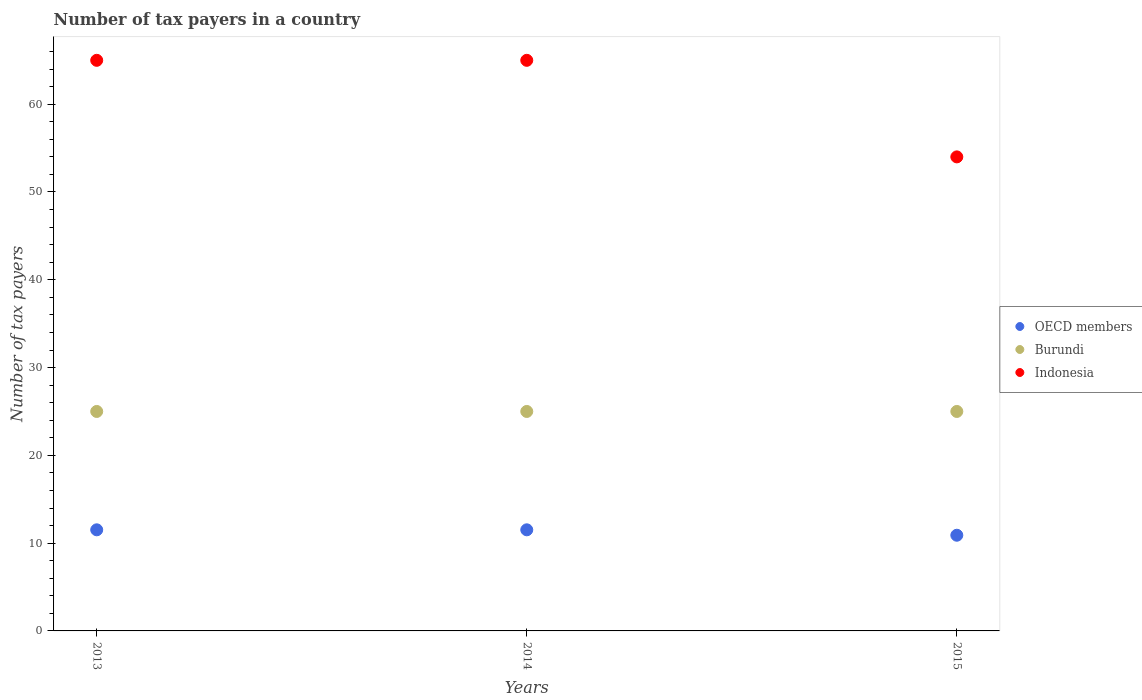What is the number of tax payers in in Indonesia in 2013?
Your response must be concise. 65. Across all years, what is the maximum number of tax payers in in Burundi?
Provide a succinct answer. 25. Across all years, what is the minimum number of tax payers in in Burundi?
Offer a very short reply. 25. In which year was the number of tax payers in in OECD members minimum?
Keep it short and to the point. 2015. What is the total number of tax payers in in Burundi in the graph?
Make the answer very short. 75. What is the difference between the number of tax payers in in OECD members in 2015 and the number of tax payers in in Burundi in 2014?
Offer a very short reply. -14.1. In the year 2013, what is the difference between the number of tax payers in in OECD members and number of tax payers in in Burundi?
Offer a terse response. -13.48. In how many years, is the number of tax payers in in OECD members greater than 16?
Keep it short and to the point. 0. What is the ratio of the number of tax payers in in OECD members in 2014 to that in 2015?
Keep it short and to the point. 1.06. Is the number of tax payers in in OECD members in 2013 less than that in 2015?
Give a very brief answer. No. What is the difference between the highest and the second highest number of tax payers in in Burundi?
Your answer should be very brief. 0. In how many years, is the number of tax payers in in Indonesia greater than the average number of tax payers in in Indonesia taken over all years?
Give a very brief answer. 2. Is the sum of the number of tax payers in in OECD members in 2013 and 2014 greater than the maximum number of tax payers in in Burundi across all years?
Your answer should be compact. No. Does the number of tax payers in in Burundi monotonically increase over the years?
Your answer should be very brief. No. Is the number of tax payers in in Burundi strictly greater than the number of tax payers in in OECD members over the years?
Offer a terse response. Yes. Is the number of tax payers in in OECD members strictly less than the number of tax payers in in Burundi over the years?
Give a very brief answer. Yes. How many dotlines are there?
Offer a terse response. 3. How many years are there in the graph?
Make the answer very short. 3. Does the graph contain any zero values?
Your answer should be compact. No. Where does the legend appear in the graph?
Your answer should be compact. Center right. How many legend labels are there?
Make the answer very short. 3. What is the title of the graph?
Ensure brevity in your answer.  Number of tax payers in a country. What is the label or title of the X-axis?
Ensure brevity in your answer.  Years. What is the label or title of the Y-axis?
Your answer should be very brief. Number of tax payers. What is the Number of tax payers in OECD members in 2013?
Provide a short and direct response. 11.52. What is the Number of tax payers of Indonesia in 2013?
Provide a short and direct response. 65. What is the Number of tax payers of OECD members in 2014?
Keep it short and to the point. 11.52. What is the Number of tax payers in Burundi in 2014?
Keep it short and to the point. 25. Across all years, what is the maximum Number of tax payers of OECD members?
Your answer should be compact. 11.52. Across all years, what is the minimum Number of tax payers in OECD members?
Ensure brevity in your answer.  10.9. What is the total Number of tax payers in OECD members in the graph?
Offer a very short reply. 33.94. What is the total Number of tax payers in Burundi in the graph?
Make the answer very short. 75. What is the total Number of tax payers in Indonesia in the graph?
Keep it short and to the point. 184. What is the difference between the Number of tax payers in OECD members in 2013 and that in 2014?
Offer a very short reply. 0. What is the difference between the Number of tax payers of Indonesia in 2013 and that in 2014?
Keep it short and to the point. 0. What is the difference between the Number of tax payers of OECD members in 2013 and that in 2015?
Make the answer very short. 0.62. What is the difference between the Number of tax payers in Burundi in 2013 and that in 2015?
Provide a succinct answer. 0. What is the difference between the Number of tax payers of Indonesia in 2013 and that in 2015?
Your answer should be compact. 11. What is the difference between the Number of tax payers in OECD members in 2014 and that in 2015?
Offer a very short reply. 0.62. What is the difference between the Number of tax payers of OECD members in 2013 and the Number of tax payers of Burundi in 2014?
Offer a very short reply. -13.48. What is the difference between the Number of tax payers in OECD members in 2013 and the Number of tax payers in Indonesia in 2014?
Ensure brevity in your answer.  -53.48. What is the difference between the Number of tax payers in Burundi in 2013 and the Number of tax payers in Indonesia in 2014?
Give a very brief answer. -40. What is the difference between the Number of tax payers of OECD members in 2013 and the Number of tax payers of Burundi in 2015?
Provide a succinct answer. -13.48. What is the difference between the Number of tax payers of OECD members in 2013 and the Number of tax payers of Indonesia in 2015?
Provide a succinct answer. -42.48. What is the difference between the Number of tax payers of Burundi in 2013 and the Number of tax payers of Indonesia in 2015?
Your answer should be compact. -29. What is the difference between the Number of tax payers in OECD members in 2014 and the Number of tax payers in Burundi in 2015?
Provide a short and direct response. -13.48. What is the difference between the Number of tax payers of OECD members in 2014 and the Number of tax payers of Indonesia in 2015?
Give a very brief answer. -42.48. What is the average Number of tax payers of OECD members per year?
Ensure brevity in your answer.  11.31. What is the average Number of tax payers in Burundi per year?
Your answer should be very brief. 25. What is the average Number of tax payers of Indonesia per year?
Offer a very short reply. 61.33. In the year 2013, what is the difference between the Number of tax payers of OECD members and Number of tax payers of Burundi?
Your response must be concise. -13.48. In the year 2013, what is the difference between the Number of tax payers in OECD members and Number of tax payers in Indonesia?
Ensure brevity in your answer.  -53.48. In the year 2014, what is the difference between the Number of tax payers of OECD members and Number of tax payers of Burundi?
Your response must be concise. -13.48. In the year 2014, what is the difference between the Number of tax payers in OECD members and Number of tax payers in Indonesia?
Keep it short and to the point. -53.48. In the year 2015, what is the difference between the Number of tax payers of OECD members and Number of tax payers of Burundi?
Provide a succinct answer. -14.1. In the year 2015, what is the difference between the Number of tax payers of OECD members and Number of tax payers of Indonesia?
Give a very brief answer. -43.1. In the year 2015, what is the difference between the Number of tax payers of Burundi and Number of tax payers of Indonesia?
Provide a short and direct response. -29. What is the ratio of the Number of tax payers of Burundi in 2013 to that in 2014?
Offer a very short reply. 1. What is the ratio of the Number of tax payers of Indonesia in 2013 to that in 2014?
Keep it short and to the point. 1. What is the ratio of the Number of tax payers of OECD members in 2013 to that in 2015?
Provide a short and direct response. 1.06. What is the ratio of the Number of tax payers in Burundi in 2013 to that in 2015?
Ensure brevity in your answer.  1. What is the ratio of the Number of tax payers of Indonesia in 2013 to that in 2015?
Provide a short and direct response. 1.2. What is the ratio of the Number of tax payers of OECD members in 2014 to that in 2015?
Ensure brevity in your answer.  1.06. What is the ratio of the Number of tax payers in Burundi in 2014 to that in 2015?
Give a very brief answer. 1. What is the ratio of the Number of tax payers of Indonesia in 2014 to that in 2015?
Your answer should be compact. 1.2. What is the difference between the highest and the second highest Number of tax payers of Burundi?
Provide a short and direct response. 0. What is the difference between the highest and the lowest Number of tax payers of OECD members?
Keep it short and to the point. 0.62. What is the difference between the highest and the lowest Number of tax payers of Burundi?
Provide a succinct answer. 0. What is the difference between the highest and the lowest Number of tax payers of Indonesia?
Your answer should be compact. 11. 